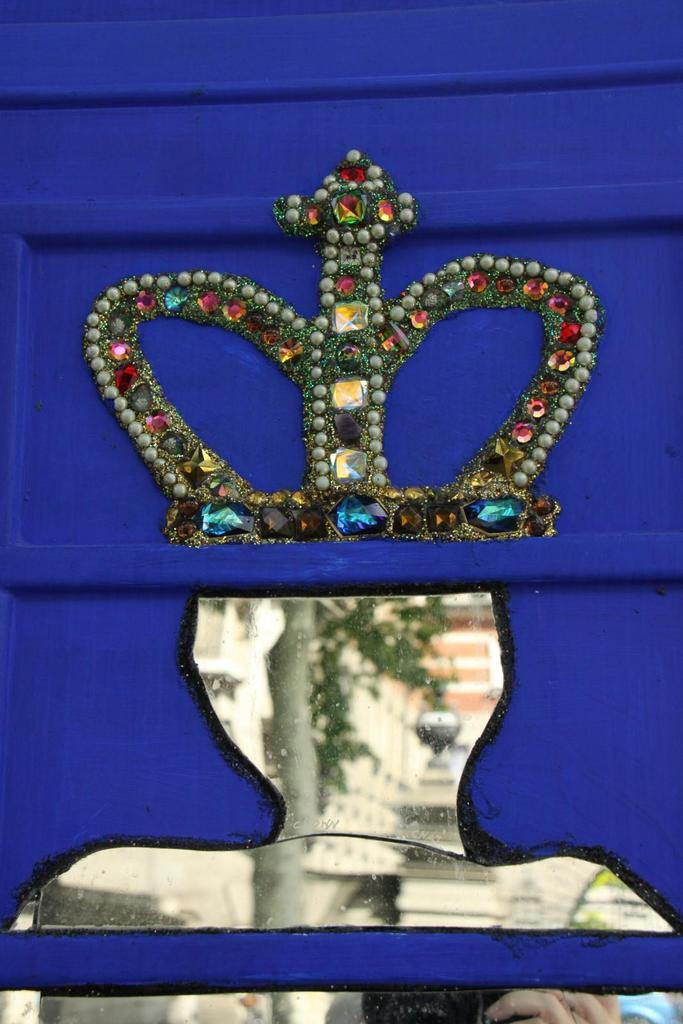What is the main subject of the artwork in the image? The main subject of the artwork in the image is a crown. What other objects can be seen in the artwork? There are no other objects mentioned in the artwork, only the crown. What is the object located on the right side of the image? There is a mirror in the image. What type of architectural feature is present in the image? There is an object that looks like a wall in the image. How many dinosaurs are visible in the image? There are no dinosaurs present in the image. What type of bread can be seen on the wall in the image? There is no bread present on the wall in the image. 